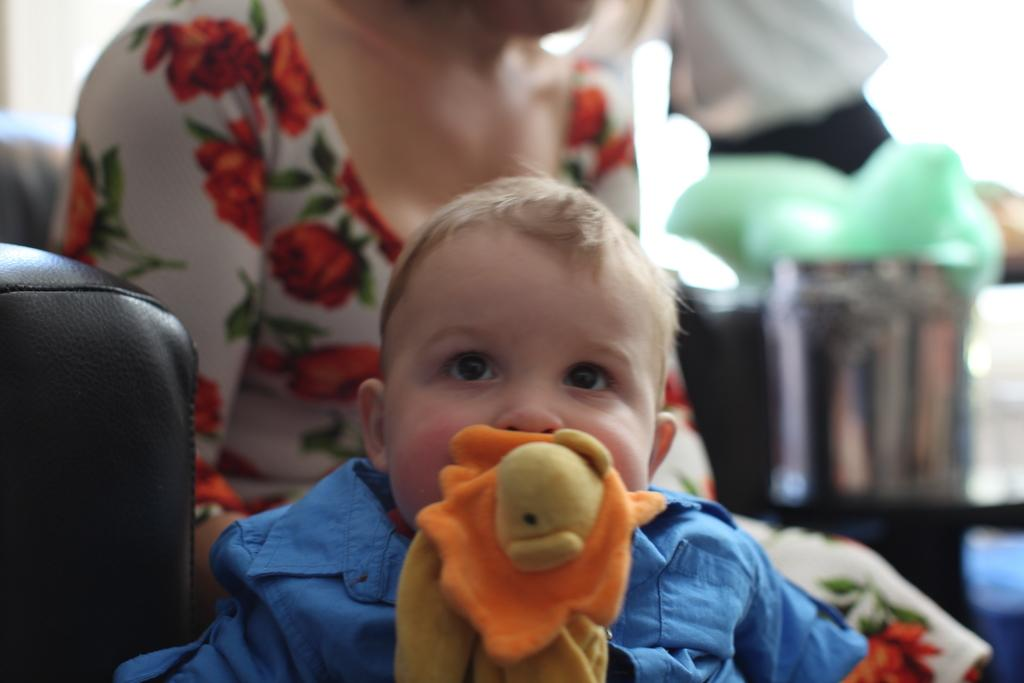What is the main subject of the image? There is a baby in the image. What is the baby wearing? The baby is wearing clothes. What is the baby doing with the toy? The baby is holding a toy in its mouth. Who is present in the image besides the baby? There is a woman sitting behind the baby. What is the woman wearing? The woman is wearing clothes. How would you describe the background of the image? The background of the image is blurred. What type of ticket is visible in the baby's hand in the image? There is no ticket visible in the baby's hand in the image. What kind of oil is being used to create the art in the image? There is no art or oil present in the image. 